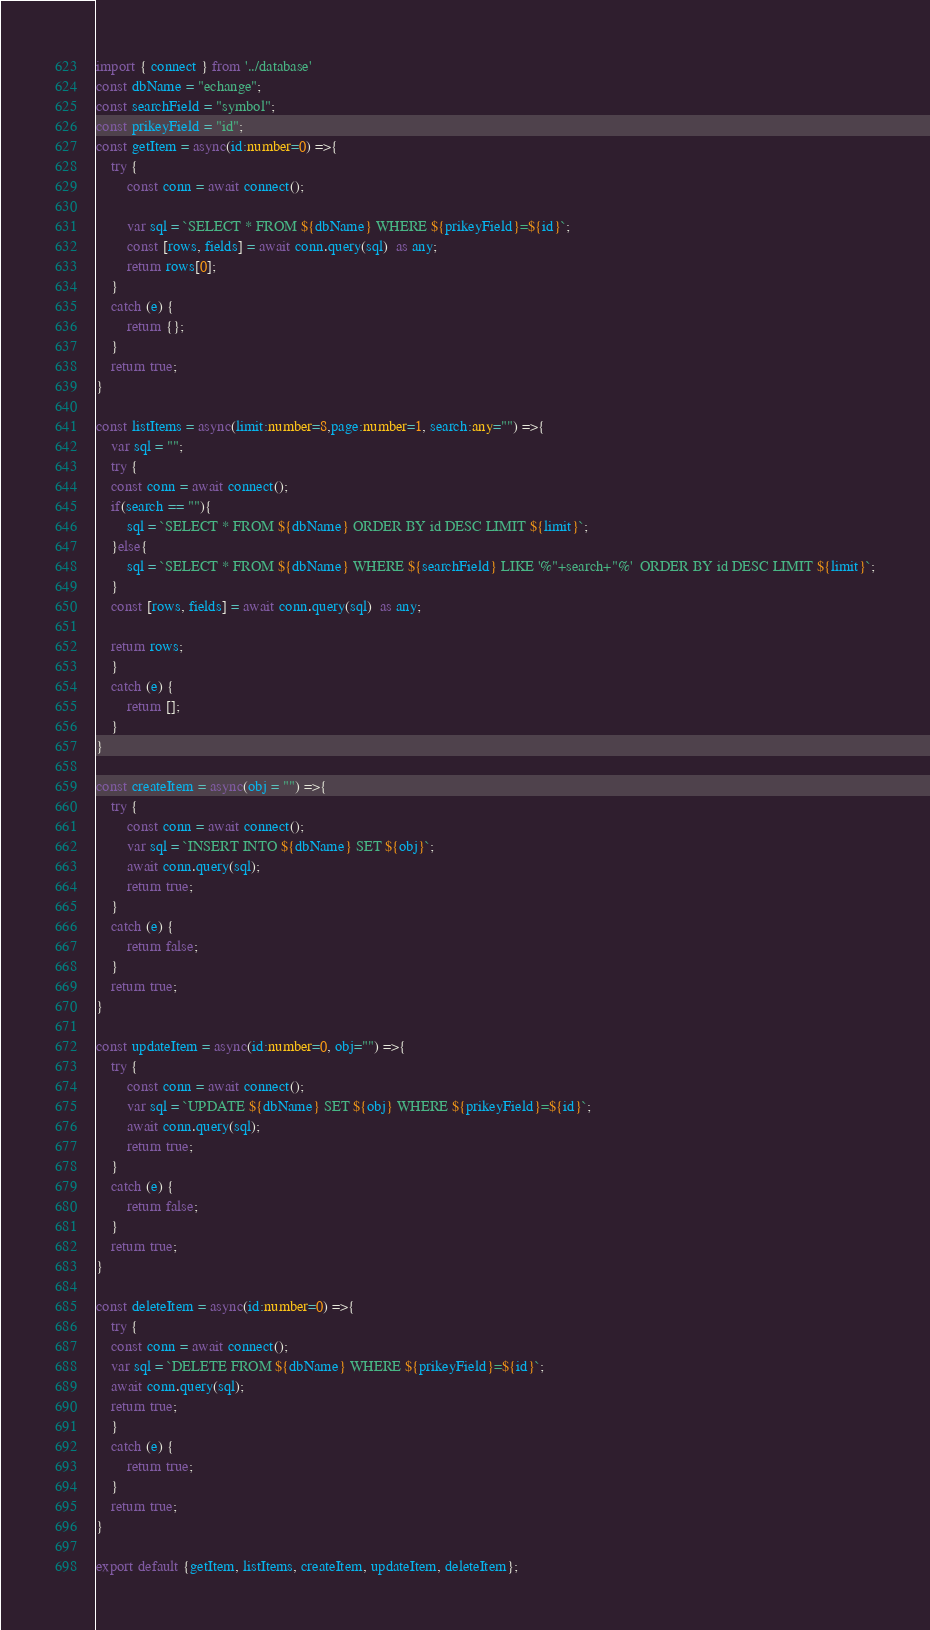Convert code to text. <code><loc_0><loc_0><loc_500><loc_500><_TypeScript_>import { connect } from '../database'
const dbName = "echange";
const searchField = "symbol";
const prikeyField = "id";
const getItem = async(id:number=0) =>{
	try {
        const conn = await connect();
        
        var sql = `SELECT * FROM ${dbName} WHERE ${prikeyField}=${id}`;
        const [rows, fields] = await conn.query(sql)  as any;
        return rows[0];
    }
    catch (e) {
        return {};
    }
    return true;
}

const listItems = async(limit:number=8,page:number=1, search:any="") =>{
	var sql = "";
    try {
    const conn = await connect();
    if(search == ""){
        sql = `SELECT * FROM ${dbName} ORDER BY id DESC LIMIT ${limit}`;
    }else{
        sql = `SELECT * FROM ${dbName} WHERE ${searchField} LIKE '%"+search+"%'  ORDER BY id DESC LIMIT ${limit}`;
    }
    const [rows, fields] = await conn.query(sql)  as any;
    
    return rows;
    }
    catch (e) {
        return [];
    }
}

const createItem = async(obj = "") =>{
	try {
        const conn = await connect();
        var sql = `INSERT INTO ${dbName} SET ${obj}`;
        await conn.query(sql);
        return true;
    }
    catch (e) {
        return false;
    }
    return true;
}

const updateItem = async(id:number=0, obj="") =>{
	try {
        const conn = await connect();
        var sql = `UPDATE ${dbName} SET ${obj} WHERE ${prikeyField}=${id}`;
        await conn.query(sql);
        return true;
    }
    catch (e) {
        return false;
    }
    return true;
}

const deleteItem = async(id:number=0) =>{
	try {
    const conn = await connect();
    var sql = `DELETE FROM ${dbName} WHERE ${prikeyField}=${id}`;
    await conn.query(sql);
    return true;
    }
    catch (e) {
        return true;
    }
    return true;
}

export default {getItem, listItems, createItem, updateItem, deleteItem};</code> 